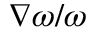Convert formula to latex. <formula><loc_0><loc_0><loc_500><loc_500>\nabla \omega / \omega</formula> 